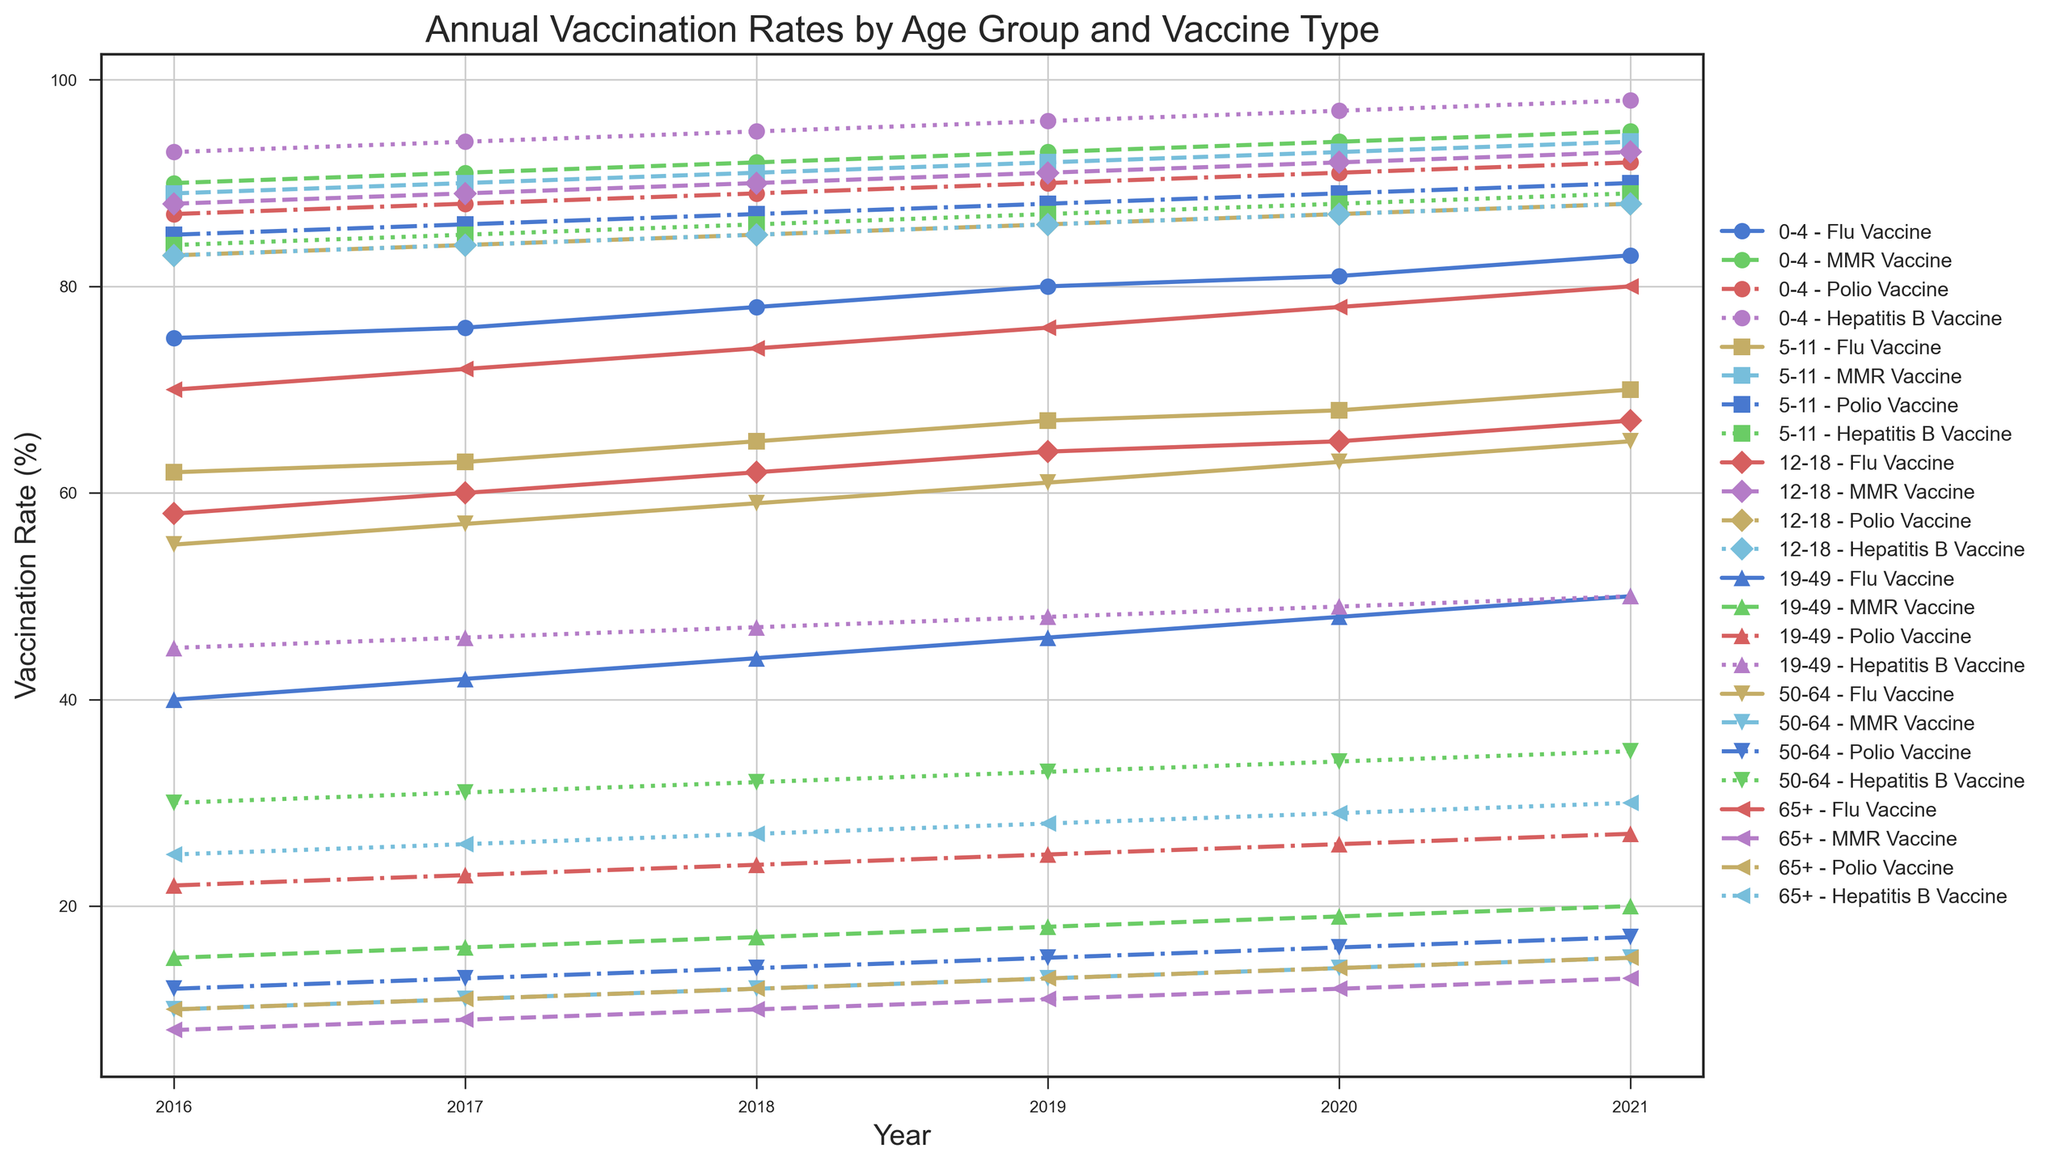What is the vaccination rate for the Hepatitis B vaccine in the 0-4 age group in 2021? Look at the line for the 0-4 age group and find the point corresponding to the year 2021 for the Hepatitis B vaccine.
Answer: 98 Which age group had the lowest flu vaccination rate in 2016, and what was the rate? Find the flu vaccination rates for all age groups in 2016 and identify the minimum value.
Answer: 19-49 age group, 40 How did the MMR vaccination rate change for the 65+ age group from 2016 to 2021? Check the MMR vaccination rates for the 65+ age group in 2016 and 2021 and calculate the difference.
Answer: Increased by 5 percentage points Which age group had the steepest increase in the polio vaccination rate from 2016 to 2021? Compare the increase in polio vaccination rates across all age groups from 2016 to 2021 and identify the largest change.
Answer: 0-4 age group How did the flu vaccination rate for the 12-18 age group change from 2016 to 2021? Find the flu vaccination rates for the 12-18 age group in 2016 and 2021 and calculate the difference.
Answer: Increased by 9 percentage points Which vaccine type had the most consistent increase in vaccination rates across all age groups from 2016 to 2021? Assess the trend lines for each vaccine type and count the number of age groups that show a consistent increase in rates from 2016 to 2021.
Answer: Hepatitis B Vaccine What is the average polio vaccination rate for the 5-11 age group from 2016 to 2021? Calculate the sum of polio vaccination rates for the 5-11 age group from 2016 to 2021 and divide by the number of years (6).
Answer: 87.5 In 2020, how did the flu vaccination rate for the 50-64 age group compare to that of the 19-49 age group? Find the flu vaccination rates for both age groups in 2020 and compare them.
Answer: 50-64 age group had 15 percentage points higher rate than the 19-49 age group Which age group had the highest Hepatitis B vaccination rate in 2018 and what was the rate? Look at the Hepatitis B vaccination rates in 2018 and identify the highest value along with its corresponding age group.
Answer: 0-4 age group, 95 How did the MMR vaccination rate for the 5-11 age group change from 2017 to 2019? Check the MMR vaccination rates for the 5-11 age group in 2017 and 2019 and calculate the difference.
Answer: Increased by 2 percentage points 